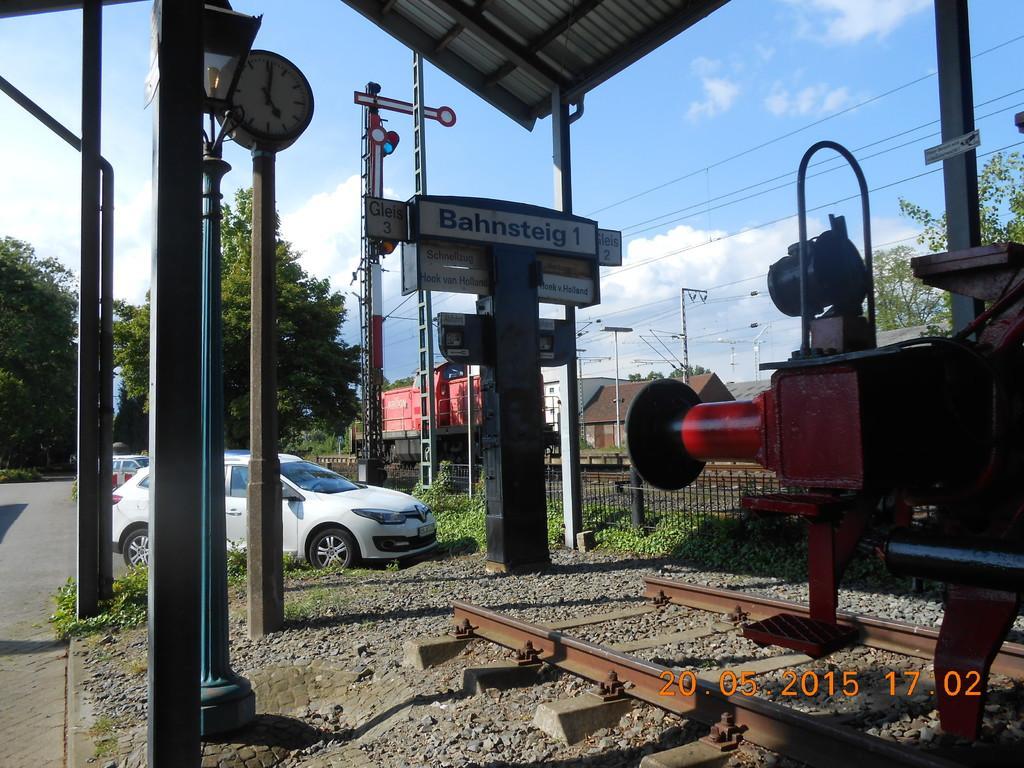In one or two sentences, can you explain what this image depicts? In this image there is a train on a railway track. Beside the train there are pillars and light poles. There are boards and a clock on the pillars. To the left there is a road. There are vehicles parked on the road. In the background there are houses and trees. There are stones and grass on the ground. Beside the train there is a fence. At the top there is the sky. 